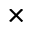Convert formula to latex. <formula><loc_0><loc_0><loc_500><loc_500>\times</formula> 